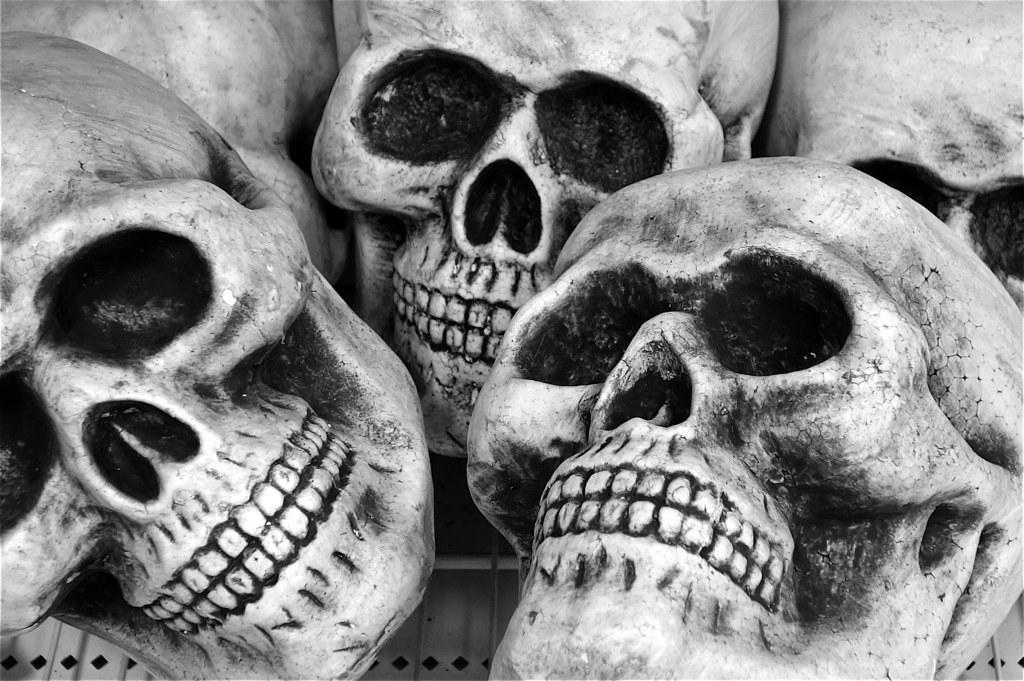What is the color scheme of the image? The image is black and white. What objects are depicted in the image? There are skulls in the image. How are the skulls arranged or positioned? The skulls are on a welded wire mesh. What is the wire mesh placed on? The wire mesh is on a platform. Can you tell me how many goldfish are swimming in the bucket in the image? There is no bucket or goldfish present in the image; it features skulls on a welded wire mesh. What color are the eyes of the goldfish in the image? There are no goldfish or eyes present in the image. 